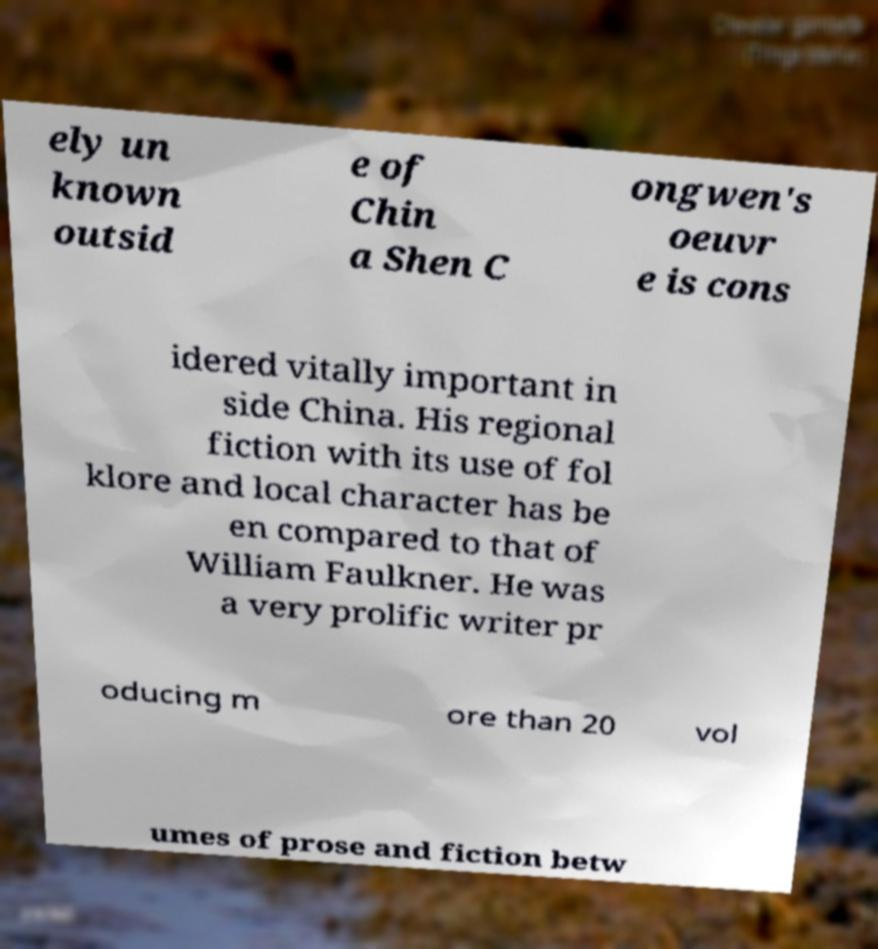Could you extract and type out the text from this image? ely un known outsid e of Chin a Shen C ongwen's oeuvr e is cons idered vitally important in side China. His regional fiction with its use of fol klore and local character has be en compared to that of William Faulkner. He was a very prolific writer pr oducing m ore than 20 vol umes of prose and fiction betw 